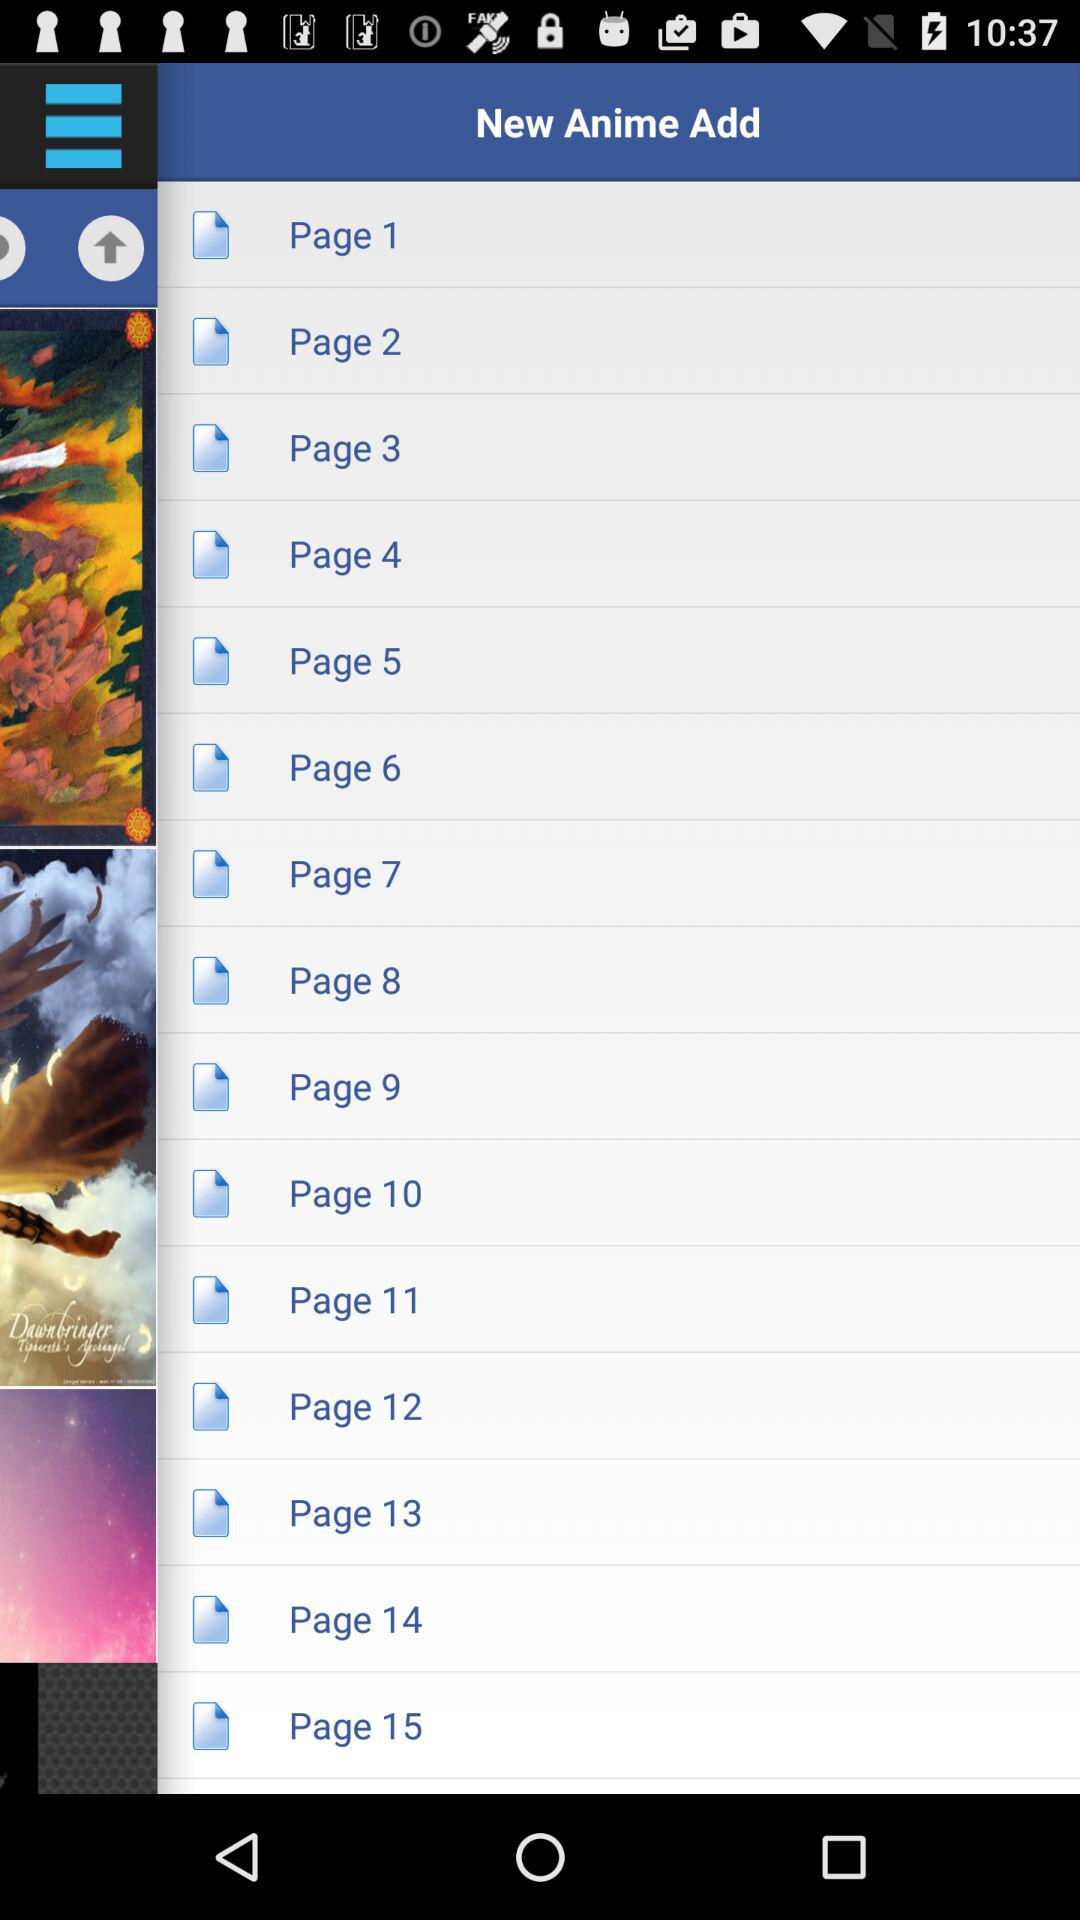How many pages are there in total?
Answer the question using a single word or phrase. 15 